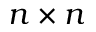Convert formula to latex. <formula><loc_0><loc_0><loc_500><loc_500>n \times n</formula> 